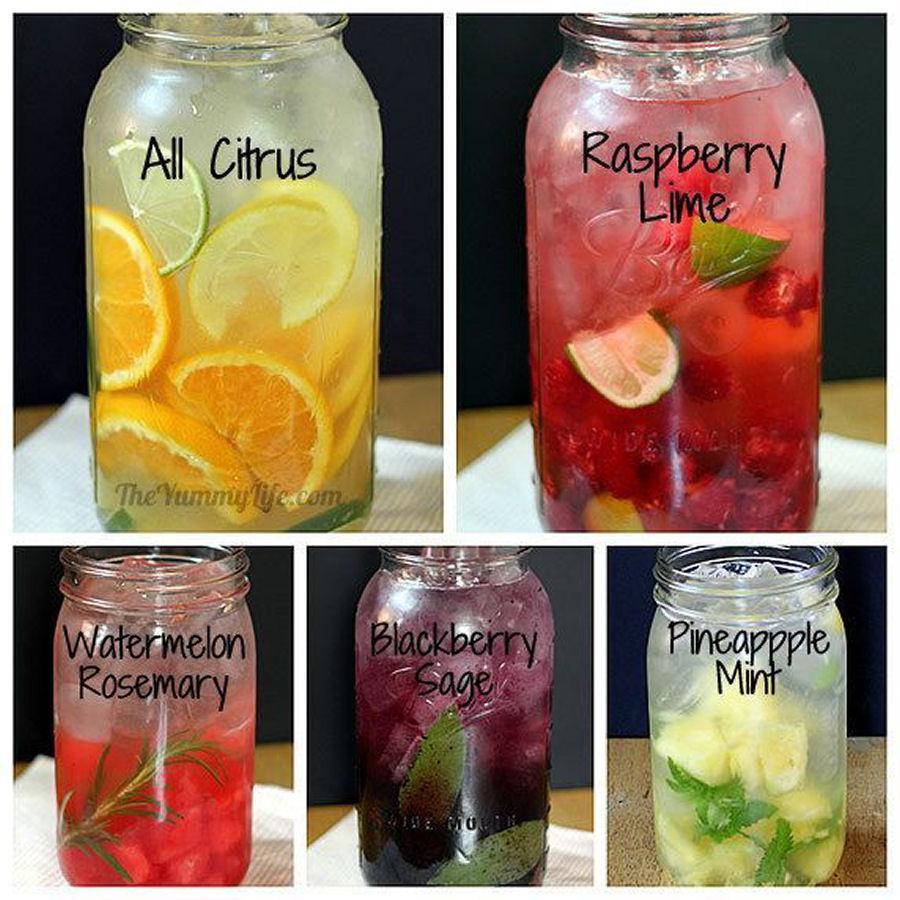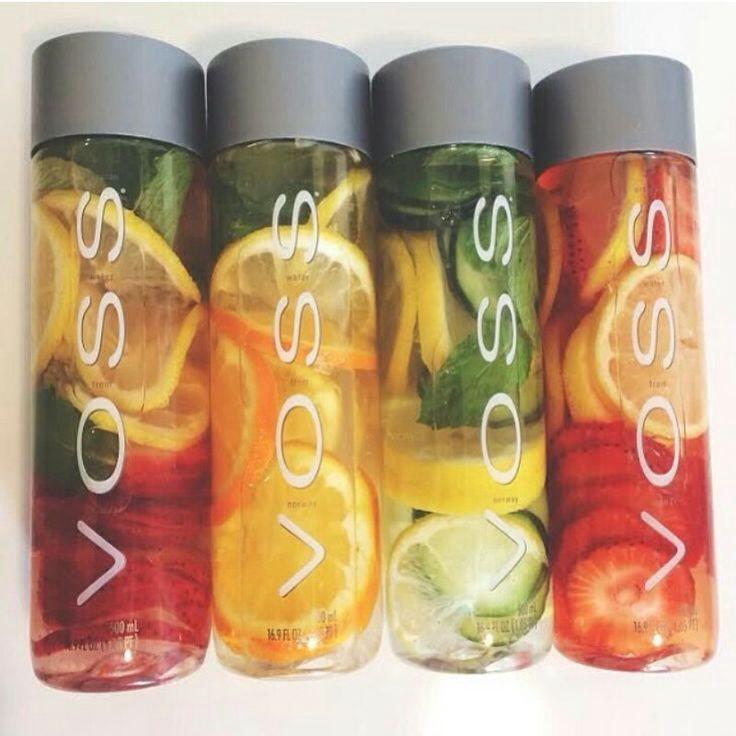The first image is the image on the left, the second image is the image on the right. For the images displayed, is the sentence "The right image shows four fruit-filled cylindrical jars arranged horizontally." factually correct? Answer yes or no. Yes. 